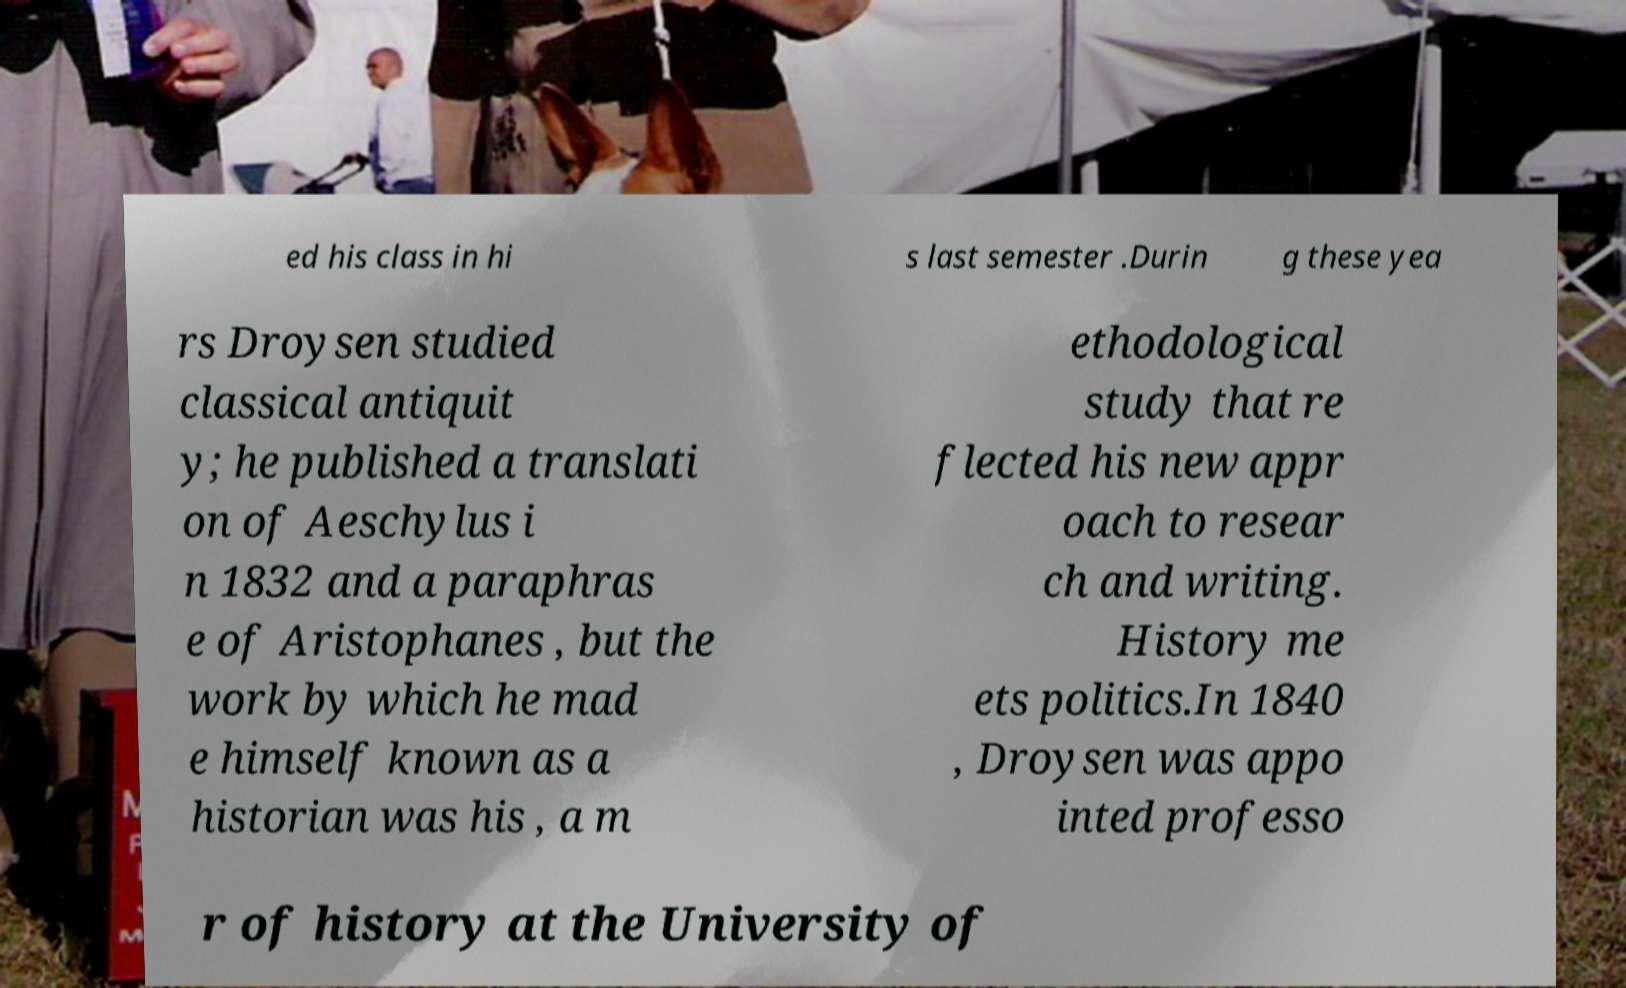Please read and relay the text visible in this image. What does it say? ed his class in hi s last semester .Durin g these yea rs Droysen studied classical antiquit y; he published a translati on of Aeschylus i n 1832 and a paraphras e of Aristophanes , but the work by which he mad e himself known as a historian was his , a m ethodological study that re flected his new appr oach to resear ch and writing. History me ets politics.In 1840 , Droysen was appo inted professo r of history at the University of 